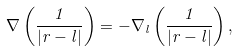Convert formula to latex. <formula><loc_0><loc_0><loc_500><loc_500>\nabla \left ( { \frac { 1 } { | r - l | } } \right ) = - \nabla _ { l } \left ( { \frac { 1 } { | r - l | } } \right ) ,</formula> 